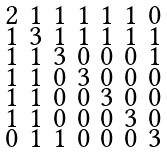<formula> <loc_0><loc_0><loc_500><loc_500>\begin{smallmatrix} 2 & 1 & 1 & 1 & 1 & 1 & 0 \\ 1 & 3 & 1 & 1 & 1 & 1 & 1 \\ 1 & 1 & 3 & 0 & 0 & 0 & 1 \\ 1 & 1 & 0 & 3 & 0 & 0 & 0 \\ 1 & 1 & 0 & 0 & 3 & 0 & 0 \\ 1 & 1 & 0 & 0 & 0 & 3 & 0 \\ 0 & 1 & 1 & 0 & 0 & 0 & 3 \end{smallmatrix}</formula> 